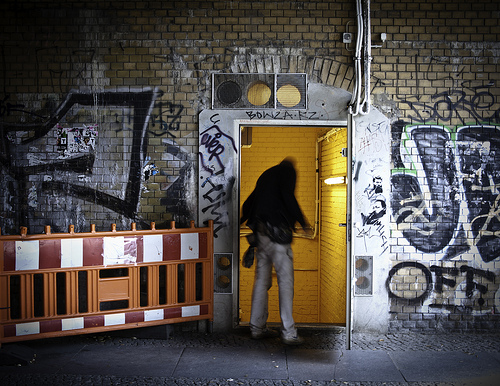Describe any signs of life or activity you can deduce from this scene. A single figure is captured in motion, entering the yellow-door building. This suggests a possible fleeting or secretive element to their movement, hinting at an untold narrative of hurry or necessity within this gritty backdrop. Is there a symbolism to the location of the hole covered by a wire grate? Indeed, the enforced grate over the hole might symbolize protection or restriction, an urban society's attempt to maintain control over the disorder that the graffiti represents. 